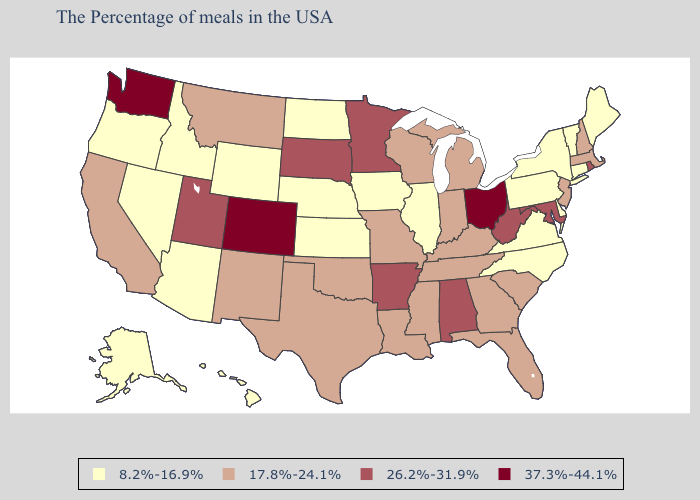Which states have the highest value in the USA?
Be succinct. Ohio, Colorado, Washington. Name the states that have a value in the range 26.2%-31.9%?
Short answer required. Rhode Island, Maryland, West Virginia, Alabama, Arkansas, Minnesota, South Dakota, Utah. What is the value of Texas?
Quick response, please. 17.8%-24.1%. Name the states that have a value in the range 26.2%-31.9%?
Be succinct. Rhode Island, Maryland, West Virginia, Alabama, Arkansas, Minnesota, South Dakota, Utah. Does New Mexico have the same value as Rhode Island?
Concise answer only. No. Does Washington have the lowest value in the West?
Be succinct. No. Which states hav the highest value in the South?
Concise answer only. Maryland, West Virginia, Alabama, Arkansas. Name the states that have a value in the range 26.2%-31.9%?
Answer briefly. Rhode Island, Maryland, West Virginia, Alabama, Arkansas, Minnesota, South Dakota, Utah. Does Utah have a lower value than Washington?
Concise answer only. Yes. How many symbols are there in the legend?
Be succinct. 4. Name the states that have a value in the range 8.2%-16.9%?
Answer briefly. Maine, Vermont, Connecticut, New York, Delaware, Pennsylvania, Virginia, North Carolina, Illinois, Iowa, Kansas, Nebraska, North Dakota, Wyoming, Arizona, Idaho, Nevada, Oregon, Alaska, Hawaii. What is the lowest value in states that border New Hampshire?
Be succinct. 8.2%-16.9%. What is the lowest value in the MidWest?
Quick response, please. 8.2%-16.9%. Which states have the highest value in the USA?
Give a very brief answer. Ohio, Colorado, Washington. What is the highest value in the MidWest ?
Concise answer only. 37.3%-44.1%. 